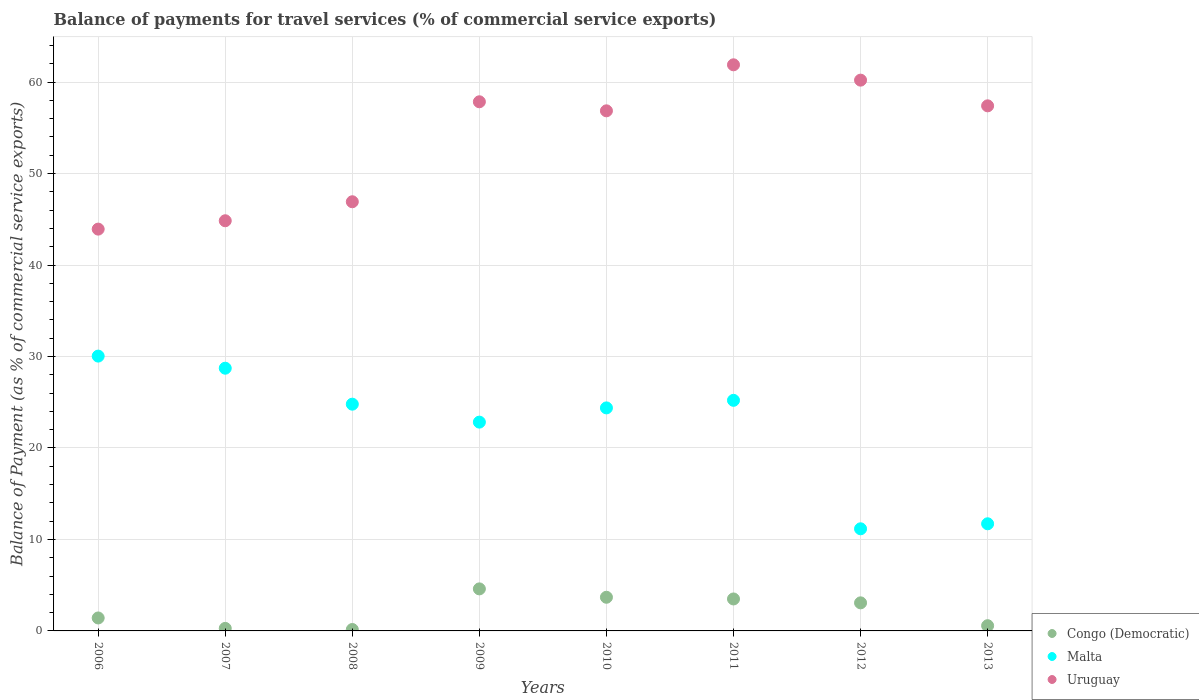How many different coloured dotlines are there?
Ensure brevity in your answer.  3. Is the number of dotlines equal to the number of legend labels?
Your answer should be compact. Yes. What is the balance of payments for travel services in Malta in 2010?
Offer a terse response. 24.38. Across all years, what is the maximum balance of payments for travel services in Malta?
Your answer should be compact. 30.05. Across all years, what is the minimum balance of payments for travel services in Congo (Democratic)?
Your response must be concise. 0.16. In which year was the balance of payments for travel services in Malta maximum?
Give a very brief answer. 2006. In which year was the balance of payments for travel services in Malta minimum?
Your response must be concise. 2012. What is the total balance of payments for travel services in Uruguay in the graph?
Make the answer very short. 429.91. What is the difference between the balance of payments for travel services in Uruguay in 2006 and that in 2010?
Give a very brief answer. -12.93. What is the difference between the balance of payments for travel services in Malta in 2013 and the balance of payments for travel services in Congo (Democratic) in 2008?
Offer a very short reply. 11.56. What is the average balance of payments for travel services in Malta per year?
Your answer should be compact. 22.36. In the year 2013, what is the difference between the balance of payments for travel services in Malta and balance of payments for travel services in Congo (Democratic)?
Offer a very short reply. 11.14. In how many years, is the balance of payments for travel services in Malta greater than 34 %?
Offer a very short reply. 0. What is the ratio of the balance of payments for travel services in Congo (Democratic) in 2006 to that in 2009?
Provide a short and direct response. 0.31. Is the difference between the balance of payments for travel services in Malta in 2006 and 2012 greater than the difference between the balance of payments for travel services in Congo (Democratic) in 2006 and 2012?
Provide a short and direct response. Yes. What is the difference between the highest and the second highest balance of payments for travel services in Malta?
Your answer should be compact. 1.32. What is the difference between the highest and the lowest balance of payments for travel services in Uruguay?
Make the answer very short. 17.96. Is it the case that in every year, the sum of the balance of payments for travel services in Congo (Democratic) and balance of payments for travel services in Uruguay  is greater than the balance of payments for travel services in Malta?
Your answer should be compact. Yes. Is the balance of payments for travel services in Malta strictly less than the balance of payments for travel services in Uruguay over the years?
Give a very brief answer. Yes. How many dotlines are there?
Offer a very short reply. 3. How many years are there in the graph?
Give a very brief answer. 8. What is the difference between two consecutive major ticks on the Y-axis?
Keep it short and to the point. 10. Are the values on the major ticks of Y-axis written in scientific E-notation?
Give a very brief answer. No. Does the graph contain any zero values?
Offer a terse response. No. How many legend labels are there?
Provide a succinct answer. 3. What is the title of the graph?
Offer a very short reply. Balance of payments for travel services (% of commercial service exports). Does "Chile" appear as one of the legend labels in the graph?
Give a very brief answer. No. What is the label or title of the Y-axis?
Offer a very short reply. Balance of Payment (as % of commercial service exports). What is the Balance of Payment (as % of commercial service exports) in Congo (Democratic) in 2006?
Offer a terse response. 1.42. What is the Balance of Payment (as % of commercial service exports) in Malta in 2006?
Give a very brief answer. 30.05. What is the Balance of Payment (as % of commercial service exports) of Uruguay in 2006?
Ensure brevity in your answer.  43.93. What is the Balance of Payment (as % of commercial service exports) in Congo (Democratic) in 2007?
Keep it short and to the point. 0.28. What is the Balance of Payment (as % of commercial service exports) in Malta in 2007?
Make the answer very short. 28.72. What is the Balance of Payment (as % of commercial service exports) in Uruguay in 2007?
Offer a very short reply. 44.84. What is the Balance of Payment (as % of commercial service exports) in Congo (Democratic) in 2008?
Give a very brief answer. 0.16. What is the Balance of Payment (as % of commercial service exports) in Malta in 2008?
Your response must be concise. 24.79. What is the Balance of Payment (as % of commercial service exports) in Uruguay in 2008?
Provide a short and direct response. 46.92. What is the Balance of Payment (as % of commercial service exports) of Congo (Democratic) in 2009?
Offer a very short reply. 4.6. What is the Balance of Payment (as % of commercial service exports) of Malta in 2009?
Offer a very short reply. 22.83. What is the Balance of Payment (as % of commercial service exports) in Uruguay in 2009?
Give a very brief answer. 57.85. What is the Balance of Payment (as % of commercial service exports) of Congo (Democratic) in 2010?
Provide a short and direct response. 3.68. What is the Balance of Payment (as % of commercial service exports) of Malta in 2010?
Ensure brevity in your answer.  24.38. What is the Balance of Payment (as % of commercial service exports) of Uruguay in 2010?
Keep it short and to the point. 56.86. What is the Balance of Payment (as % of commercial service exports) of Congo (Democratic) in 2011?
Provide a short and direct response. 3.49. What is the Balance of Payment (as % of commercial service exports) in Malta in 2011?
Make the answer very short. 25.21. What is the Balance of Payment (as % of commercial service exports) in Uruguay in 2011?
Keep it short and to the point. 61.89. What is the Balance of Payment (as % of commercial service exports) in Congo (Democratic) in 2012?
Make the answer very short. 3.07. What is the Balance of Payment (as % of commercial service exports) of Malta in 2012?
Give a very brief answer. 11.16. What is the Balance of Payment (as % of commercial service exports) in Uruguay in 2012?
Make the answer very short. 60.21. What is the Balance of Payment (as % of commercial service exports) of Congo (Democratic) in 2013?
Your answer should be compact. 0.57. What is the Balance of Payment (as % of commercial service exports) of Malta in 2013?
Keep it short and to the point. 11.71. What is the Balance of Payment (as % of commercial service exports) of Uruguay in 2013?
Provide a short and direct response. 57.41. Across all years, what is the maximum Balance of Payment (as % of commercial service exports) in Congo (Democratic)?
Keep it short and to the point. 4.6. Across all years, what is the maximum Balance of Payment (as % of commercial service exports) in Malta?
Offer a terse response. 30.05. Across all years, what is the maximum Balance of Payment (as % of commercial service exports) in Uruguay?
Your answer should be compact. 61.89. Across all years, what is the minimum Balance of Payment (as % of commercial service exports) of Congo (Democratic)?
Your answer should be compact. 0.16. Across all years, what is the minimum Balance of Payment (as % of commercial service exports) of Malta?
Provide a short and direct response. 11.16. Across all years, what is the minimum Balance of Payment (as % of commercial service exports) of Uruguay?
Ensure brevity in your answer.  43.93. What is the total Balance of Payment (as % of commercial service exports) in Congo (Democratic) in the graph?
Give a very brief answer. 17.26. What is the total Balance of Payment (as % of commercial service exports) in Malta in the graph?
Offer a very short reply. 178.85. What is the total Balance of Payment (as % of commercial service exports) of Uruguay in the graph?
Make the answer very short. 429.91. What is the difference between the Balance of Payment (as % of commercial service exports) in Congo (Democratic) in 2006 and that in 2007?
Offer a very short reply. 1.14. What is the difference between the Balance of Payment (as % of commercial service exports) of Malta in 2006 and that in 2007?
Make the answer very short. 1.32. What is the difference between the Balance of Payment (as % of commercial service exports) of Uruguay in 2006 and that in 2007?
Make the answer very short. -0.91. What is the difference between the Balance of Payment (as % of commercial service exports) in Congo (Democratic) in 2006 and that in 2008?
Your answer should be very brief. 1.26. What is the difference between the Balance of Payment (as % of commercial service exports) of Malta in 2006 and that in 2008?
Give a very brief answer. 5.26. What is the difference between the Balance of Payment (as % of commercial service exports) of Uruguay in 2006 and that in 2008?
Make the answer very short. -2.99. What is the difference between the Balance of Payment (as % of commercial service exports) of Congo (Democratic) in 2006 and that in 2009?
Your answer should be very brief. -3.18. What is the difference between the Balance of Payment (as % of commercial service exports) of Malta in 2006 and that in 2009?
Offer a very short reply. 7.22. What is the difference between the Balance of Payment (as % of commercial service exports) of Uruguay in 2006 and that in 2009?
Provide a succinct answer. -13.92. What is the difference between the Balance of Payment (as % of commercial service exports) in Congo (Democratic) in 2006 and that in 2010?
Provide a short and direct response. -2.26. What is the difference between the Balance of Payment (as % of commercial service exports) in Malta in 2006 and that in 2010?
Your response must be concise. 5.66. What is the difference between the Balance of Payment (as % of commercial service exports) in Uruguay in 2006 and that in 2010?
Offer a terse response. -12.93. What is the difference between the Balance of Payment (as % of commercial service exports) in Congo (Democratic) in 2006 and that in 2011?
Your answer should be very brief. -2.08. What is the difference between the Balance of Payment (as % of commercial service exports) of Malta in 2006 and that in 2011?
Offer a terse response. 4.84. What is the difference between the Balance of Payment (as % of commercial service exports) in Uruguay in 2006 and that in 2011?
Your answer should be compact. -17.96. What is the difference between the Balance of Payment (as % of commercial service exports) of Congo (Democratic) in 2006 and that in 2012?
Make the answer very short. -1.65. What is the difference between the Balance of Payment (as % of commercial service exports) of Malta in 2006 and that in 2012?
Your response must be concise. 18.88. What is the difference between the Balance of Payment (as % of commercial service exports) in Uruguay in 2006 and that in 2012?
Your response must be concise. -16.29. What is the difference between the Balance of Payment (as % of commercial service exports) in Congo (Democratic) in 2006 and that in 2013?
Your answer should be compact. 0.85. What is the difference between the Balance of Payment (as % of commercial service exports) in Malta in 2006 and that in 2013?
Provide a succinct answer. 18.33. What is the difference between the Balance of Payment (as % of commercial service exports) of Uruguay in 2006 and that in 2013?
Ensure brevity in your answer.  -13.48. What is the difference between the Balance of Payment (as % of commercial service exports) in Congo (Democratic) in 2007 and that in 2008?
Make the answer very short. 0.12. What is the difference between the Balance of Payment (as % of commercial service exports) of Malta in 2007 and that in 2008?
Your answer should be very brief. 3.93. What is the difference between the Balance of Payment (as % of commercial service exports) of Uruguay in 2007 and that in 2008?
Your answer should be compact. -2.08. What is the difference between the Balance of Payment (as % of commercial service exports) of Congo (Democratic) in 2007 and that in 2009?
Offer a terse response. -4.32. What is the difference between the Balance of Payment (as % of commercial service exports) in Malta in 2007 and that in 2009?
Provide a succinct answer. 5.9. What is the difference between the Balance of Payment (as % of commercial service exports) in Uruguay in 2007 and that in 2009?
Your response must be concise. -13.01. What is the difference between the Balance of Payment (as % of commercial service exports) of Congo (Democratic) in 2007 and that in 2010?
Provide a succinct answer. -3.4. What is the difference between the Balance of Payment (as % of commercial service exports) in Malta in 2007 and that in 2010?
Offer a terse response. 4.34. What is the difference between the Balance of Payment (as % of commercial service exports) in Uruguay in 2007 and that in 2010?
Your answer should be very brief. -12.02. What is the difference between the Balance of Payment (as % of commercial service exports) of Congo (Democratic) in 2007 and that in 2011?
Your answer should be very brief. -3.22. What is the difference between the Balance of Payment (as % of commercial service exports) of Malta in 2007 and that in 2011?
Your response must be concise. 3.51. What is the difference between the Balance of Payment (as % of commercial service exports) of Uruguay in 2007 and that in 2011?
Provide a succinct answer. -17.05. What is the difference between the Balance of Payment (as % of commercial service exports) of Congo (Democratic) in 2007 and that in 2012?
Offer a very short reply. -2.79. What is the difference between the Balance of Payment (as % of commercial service exports) of Malta in 2007 and that in 2012?
Your answer should be compact. 17.56. What is the difference between the Balance of Payment (as % of commercial service exports) of Uruguay in 2007 and that in 2012?
Make the answer very short. -15.37. What is the difference between the Balance of Payment (as % of commercial service exports) of Congo (Democratic) in 2007 and that in 2013?
Provide a short and direct response. -0.29. What is the difference between the Balance of Payment (as % of commercial service exports) of Malta in 2007 and that in 2013?
Offer a very short reply. 17.01. What is the difference between the Balance of Payment (as % of commercial service exports) of Uruguay in 2007 and that in 2013?
Ensure brevity in your answer.  -12.56. What is the difference between the Balance of Payment (as % of commercial service exports) of Congo (Democratic) in 2008 and that in 2009?
Give a very brief answer. -4.44. What is the difference between the Balance of Payment (as % of commercial service exports) of Malta in 2008 and that in 2009?
Provide a short and direct response. 1.96. What is the difference between the Balance of Payment (as % of commercial service exports) in Uruguay in 2008 and that in 2009?
Offer a very short reply. -10.93. What is the difference between the Balance of Payment (as % of commercial service exports) of Congo (Democratic) in 2008 and that in 2010?
Make the answer very short. -3.52. What is the difference between the Balance of Payment (as % of commercial service exports) in Malta in 2008 and that in 2010?
Provide a short and direct response. 0.41. What is the difference between the Balance of Payment (as % of commercial service exports) in Uruguay in 2008 and that in 2010?
Your answer should be very brief. -9.94. What is the difference between the Balance of Payment (as % of commercial service exports) of Congo (Democratic) in 2008 and that in 2011?
Your response must be concise. -3.34. What is the difference between the Balance of Payment (as % of commercial service exports) in Malta in 2008 and that in 2011?
Provide a succinct answer. -0.42. What is the difference between the Balance of Payment (as % of commercial service exports) of Uruguay in 2008 and that in 2011?
Your answer should be compact. -14.97. What is the difference between the Balance of Payment (as % of commercial service exports) of Congo (Democratic) in 2008 and that in 2012?
Offer a very short reply. -2.91. What is the difference between the Balance of Payment (as % of commercial service exports) in Malta in 2008 and that in 2012?
Provide a short and direct response. 13.62. What is the difference between the Balance of Payment (as % of commercial service exports) in Uruguay in 2008 and that in 2012?
Make the answer very short. -13.3. What is the difference between the Balance of Payment (as % of commercial service exports) of Congo (Democratic) in 2008 and that in 2013?
Ensure brevity in your answer.  -0.42. What is the difference between the Balance of Payment (as % of commercial service exports) in Malta in 2008 and that in 2013?
Provide a succinct answer. 13.08. What is the difference between the Balance of Payment (as % of commercial service exports) in Uruguay in 2008 and that in 2013?
Your response must be concise. -10.49. What is the difference between the Balance of Payment (as % of commercial service exports) of Congo (Democratic) in 2009 and that in 2010?
Offer a very short reply. 0.92. What is the difference between the Balance of Payment (as % of commercial service exports) in Malta in 2009 and that in 2010?
Your answer should be very brief. -1.55. What is the difference between the Balance of Payment (as % of commercial service exports) in Uruguay in 2009 and that in 2010?
Provide a succinct answer. 0.99. What is the difference between the Balance of Payment (as % of commercial service exports) in Congo (Democratic) in 2009 and that in 2011?
Offer a terse response. 1.1. What is the difference between the Balance of Payment (as % of commercial service exports) of Malta in 2009 and that in 2011?
Provide a succinct answer. -2.38. What is the difference between the Balance of Payment (as % of commercial service exports) in Uruguay in 2009 and that in 2011?
Your answer should be very brief. -4.04. What is the difference between the Balance of Payment (as % of commercial service exports) in Congo (Democratic) in 2009 and that in 2012?
Your answer should be very brief. 1.53. What is the difference between the Balance of Payment (as % of commercial service exports) of Malta in 2009 and that in 2012?
Offer a very short reply. 11.66. What is the difference between the Balance of Payment (as % of commercial service exports) of Uruguay in 2009 and that in 2012?
Give a very brief answer. -2.37. What is the difference between the Balance of Payment (as % of commercial service exports) of Congo (Democratic) in 2009 and that in 2013?
Keep it short and to the point. 4.02. What is the difference between the Balance of Payment (as % of commercial service exports) in Malta in 2009 and that in 2013?
Offer a very short reply. 11.11. What is the difference between the Balance of Payment (as % of commercial service exports) in Uruguay in 2009 and that in 2013?
Your answer should be compact. 0.44. What is the difference between the Balance of Payment (as % of commercial service exports) in Congo (Democratic) in 2010 and that in 2011?
Offer a terse response. 0.18. What is the difference between the Balance of Payment (as % of commercial service exports) in Malta in 2010 and that in 2011?
Keep it short and to the point. -0.83. What is the difference between the Balance of Payment (as % of commercial service exports) of Uruguay in 2010 and that in 2011?
Keep it short and to the point. -5.03. What is the difference between the Balance of Payment (as % of commercial service exports) of Congo (Democratic) in 2010 and that in 2012?
Your answer should be very brief. 0.61. What is the difference between the Balance of Payment (as % of commercial service exports) in Malta in 2010 and that in 2012?
Offer a very short reply. 13.22. What is the difference between the Balance of Payment (as % of commercial service exports) in Uruguay in 2010 and that in 2012?
Provide a short and direct response. -3.35. What is the difference between the Balance of Payment (as % of commercial service exports) of Congo (Democratic) in 2010 and that in 2013?
Make the answer very short. 3.11. What is the difference between the Balance of Payment (as % of commercial service exports) of Malta in 2010 and that in 2013?
Make the answer very short. 12.67. What is the difference between the Balance of Payment (as % of commercial service exports) in Uruguay in 2010 and that in 2013?
Keep it short and to the point. -0.55. What is the difference between the Balance of Payment (as % of commercial service exports) in Congo (Democratic) in 2011 and that in 2012?
Your answer should be very brief. 0.43. What is the difference between the Balance of Payment (as % of commercial service exports) in Malta in 2011 and that in 2012?
Make the answer very short. 14.04. What is the difference between the Balance of Payment (as % of commercial service exports) in Uruguay in 2011 and that in 2012?
Make the answer very short. 1.68. What is the difference between the Balance of Payment (as % of commercial service exports) in Congo (Democratic) in 2011 and that in 2013?
Make the answer very short. 2.92. What is the difference between the Balance of Payment (as % of commercial service exports) of Malta in 2011 and that in 2013?
Provide a short and direct response. 13.5. What is the difference between the Balance of Payment (as % of commercial service exports) of Uruguay in 2011 and that in 2013?
Your answer should be compact. 4.49. What is the difference between the Balance of Payment (as % of commercial service exports) of Congo (Democratic) in 2012 and that in 2013?
Offer a terse response. 2.5. What is the difference between the Balance of Payment (as % of commercial service exports) in Malta in 2012 and that in 2013?
Give a very brief answer. -0.55. What is the difference between the Balance of Payment (as % of commercial service exports) in Uruguay in 2012 and that in 2013?
Provide a succinct answer. 2.81. What is the difference between the Balance of Payment (as % of commercial service exports) of Congo (Democratic) in 2006 and the Balance of Payment (as % of commercial service exports) of Malta in 2007?
Provide a succinct answer. -27.31. What is the difference between the Balance of Payment (as % of commercial service exports) in Congo (Democratic) in 2006 and the Balance of Payment (as % of commercial service exports) in Uruguay in 2007?
Your response must be concise. -43.43. What is the difference between the Balance of Payment (as % of commercial service exports) of Malta in 2006 and the Balance of Payment (as % of commercial service exports) of Uruguay in 2007?
Offer a very short reply. -14.8. What is the difference between the Balance of Payment (as % of commercial service exports) of Congo (Democratic) in 2006 and the Balance of Payment (as % of commercial service exports) of Malta in 2008?
Provide a succinct answer. -23.37. What is the difference between the Balance of Payment (as % of commercial service exports) of Congo (Democratic) in 2006 and the Balance of Payment (as % of commercial service exports) of Uruguay in 2008?
Your response must be concise. -45.5. What is the difference between the Balance of Payment (as % of commercial service exports) in Malta in 2006 and the Balance of Payment (as % of commercial service exports) in Uruguay in 2008?
Give a very brief answer. -16.87. What is the difference between the Balance of Payment (as % of commercial service exports) of Congo (Democratic) in 2006 and the Balance of Payment (as % of commercial service exports) of Malta in 2009?
Your answer should be very brief. -21.41. What is the difference between the Balance of Payment (as % of commercial service exports) in Congo (Democratic) in 2006 and the Balance of Payment (as % of commercial service exports) in Uruguay in 2009?
Provide a short and direct response. -56.43. What is the difference between the Balance of Payment (as % of commercial service exports) of Malta in 2006 and the Balance of Payment (as % of commercial service exports) of Uruguay in 2009?
Ensure brevity in your answer.  -27.8. What is the difference between the Balance of Payment (as % of commercial service exports) of Congo (Democratic) in 2006 and the Balance of Payment (as % of commercial service exports) of Malta in 2010?
Offer a very short reply. -22.96. What is the difference between the Balance of Payment (as % of commercial service exports) in Congo (Democratic) in 2006 and the Balance of Payment (as % of commercial service exports) in Uruguay in 2010?
Provide a succinct answer. -55.44. What is the difference between the Balance of Payment (as % of commercial service exports) in Malta in 2006 and the Balance of Payment (as % of commercial service exports) in Uruguay in 2010?
Make the answer very short. -26.81. What is the difference between the Balance of Payment (as % of commercial service exports) in Congo (Democratic) in 2006 and the Balance of Payment (as % of commercial service exports) in Malta in 2011?
Provide a short and direct response. -23.79. What is the difference between the Balance of Payment (as % of commercial service exports) in Congo (Democratic) in 2006 and the Balance of Payment (as % of commercial service exports) in Uruguay in 2011?
Give a very brief answer. -60.47. What is the difference between the Balance of Payment (as % of commercial service exports) in Malta in 2006 and the Balance of Payment (as % of commercial service exports) in Uruguay in 2011?
Give a very brief answer. -31.85. What is the difference between the Balance of Payment (as % of commercial service exports) in Congo (Democratic) in 2006 and the Balance of Payment (as % of commercial service exports) in Malta in 2012?
Your response must be concise. -9.75. What is the difference between the Balance of Payment (as % of commercial service exports) in Congo (Democratic) in 2006 and the Balance of Payment (as % of commercial service exports) in Uruguay in 2012?
Your answer should be very brief. -58.8. What is the difference between the Balance of Payment (as % of commercial service exports) of Malta in 2006 and the Balance of Payment (as % of commercial service exports) of Uruguay in 2012?
Provide a short and direct response. -30.17. What is the difference between the Balance of Payment (as % of commercial service exports) in Congo (Democratic) in 2006 and the Balance of Payment (as % of commercial service exports) in Malta in 2013?
Ensure brevity in your answer.  -10.3. What is the difference between the Balance of Payment (as % of commercial service exports) of Congo (Democratic) in 2006 and the Balance of Payment (as % of commercial service exports) of Uruguay in 2013?
Your answer should be very brief. -55.99. What is the difference between the Balance of Payment (as % of commercial service exports) of Malta in 2006 and the Balance of Payment (as % of commercial service exports) of Uruguay in 2013?
Your answer should be compact. -27.36. What is the difference between the Balance of Payment (as % of commercial service exports) in Congo (Democratic) in 2007 and the Balance of Payment (as % of commercial service exports) in Malta in 2008?
Ensure brevity in your answer.  -24.51. What is the difference between the Balance of Payment (as % of commercial service exports) in Congo (Democratic) in 2007 and the Balance of Payment (as % of commercial service exports) in Uruguay in 2008?
Provide a succinct answer. -46.64. What is the difference between the Balance of Payment (as % of commercial service exports) of Malta in 2007 and the Balance of Payment (as % of commercial service exports) of Uruguay in 2008?
Keep it short and to the point. -18.2. What is the difference between the Balance of Payment (as % of commercial service exports) of Congo (Democratic) in 2007 and the Balance of Payment (as % of commercial service exports) of Malta in 2009?
Offer a very short reply. -22.55. What is the difference between the Balance of Payment (as % of commercial service exports) of Congo (Democratic) in 2007 and the Balance of Payment (as % of commercial service exports) of Uruguay in 2009?
Your response must be concise. -57.57. What is the difference between the Balance of Payment (as % of commercial service exports) in Malta in 2007 and the Balance of Payment (as % of commercial service exports) in Uruguay in 2009?
Your answer should be compact. -29.13. What is the difference between the Balance of Payment (as % of commercial service exports) of Congo (Democratic) in 2007 and the Balance of Payment (as % of commercial service exports) of Malta in 2010?
Offer a very short reply. -24.11. What is the difference between the Balance of Payment (as % of commercial service exports) of Congo (Democratic) in 2007 and the Balance of Payment (as % of commercial service exports) of Uruguay in 2010?
Your answer should be very brief. -56.58. What is the difference between the Balance of Payment (as % of commercial service exports) of Malta in 2007 and the Balance of Payment (as % of commercial service exports) of Uruguay in 2010?
Ensure brevity in your answer.  -28.14. What is the difference between the Balance of Payment (as % of commercial service exports) of Congo (Democratic) in 2007 and the Balance of Payment (as % of commercial service exports) of Malta in 2011?
Give a very brief answer. -24.93. What is the difference between the Balance of Payment (as % of commercial service exports) of Congo (Democratic) in 2007 and the Balance of Payment (as % of commercial service exports) of Uruguay in 2011?
Provide a succinct answer. -61.61. What is the difference between the Balance of Payment (as % of commercial service exports) of Malta in 2007 and the Balance of Payment (as % of commercial service exports) of Uruguay in 2011?
Provide a succinct answer. -33.17. What is the difference between the Balance of Payment (as % of commercial service exports) in Congo (Democratic) in 2007 and the Balance of Payment (as % of commercial service exports) in Malta in 2012?
Provide a succinct answer. -10.89. What is the difference between the Balance of Payment (as % of commercial service exports) of Congo (Democratic) in 2007 and the Balance of Payment (as % of commercial service exports) of Uruguay in 2012?
Your answer should be very brief. -59.94. What is the difference between the Balance of Payment (as % of commercial service exports) in Malta in 2007 and the Balance of Payment (as % of commercial service exports) in Uruguay in 2012?
Give a very brief answer. -31.49. What is the difference between the Balance of Payment (as % of commercial service exports) of Congo (Democratic) in 2007 and the Balance of Payment (as % of commercial service exports) of Malta in 2013?
Provide a succinct answer. -11.44. What is the difference between the Balance of Payment (as % of commercial service exports) of Congo (Democratic) in 2007 and the Balance of Payment (as % of commercial service exports) of Uruguay in 2013?
Give a very brief answer. -57.13. What is the difference between the Balance of Payment (as % of commercial service exports) of Malta in 2007 and the Balance of Payment (as % of commercial service exports) of Uruguay in 2013?
Give a very brief answer. -28.68. What is the difference between the Balance of Payment (as % of commercial service exports) in Congo (Democratic) in 2008 and the Balance of Payment (as % of commercial service exports) in Malta in 2009?
Ensure brevity in your answer.  -22.67. What is the difference between the Balance of Payment (as % of commercial service exports) of Congo (Democratic) in 2008 and the Balance of Payment (as % of commercial service exports) of Uruguay in 2009?
Your answer should be very brief. -57.69. What is the difference between the Balance of Payment (as % of commercial service exports) in Malta in 2008 and the Balance of Payment (as % of commercial service exports) in Uruguay in 2009?
Provide a succinct answer. -33.06. What is the difference between the Balance of Payment (as % of commercial service exports) in Congo (Democratic) in 2008 and the Balance of Payment (as % of commercial service exports) in Malta in 2010?
Offer a very short reply. -24.23. What is the difference between the Balance of Payment (as % of commercial service exports) in Congo (Democratic) in 2008 and the Balance of Payment (as % of commercial service exports) in Uruguay in 2010?
Provide a short and direct response. -56.7. What is the difference between the Balance of Payment (as % of commercial service exports) in Malta in 2008 and the Balance of Payment (as % of commercial service exports) in Uruguay in 2010?
Your answer should be very brief. -32.07. What is the difference between the Balance of Payment (as % of commercial service exports) of Congo (Democratic) in 2008 and the Balance of Payment (as % of commercial service exports) of Malta in 2011?
Make the answer very short. -25.05. What is the difference between the Balance of Payment (as % of commercial service exports) in Congo (Democratic) in 2008 and the Balance of Payment (as % of commercial service exports) in Uruguay in 2011?
Provide a short and direct response. -61.74. What is the difference between the Balance of Payment (as % of commercial service exports) in Malta in 2008 and the Balance of Payment (as % of commercial service exports) in Uruguay in 2011?
Your response must be concise. -37.1. What is the difference between the Balance of Payment (as % of commercial service exports) of Congo (Democratic) in 2008 and the Balance of Payment (as % of commercial service exports) of Malta in 2012?
Offer a terse response. -11.01. What is the difference between the Balance of Payment (as % of commercial service exports) in Congo (Democratic) in 2008 and the Balance of Payment (as % of commercial service exports) in Uruguay in 2012?
Provide a succinct answer. -60.06. What is the difference between the Balance of Payment (as % of commercial service exports) in Malta in 2008 and the Balance of Payment (as % of commercial service exports) in Uruguay in 2012?
Make the answer very short. -35.43. What is the difference between the Balance of Payment (as % of commercial service exports) of Congo (Democratic) in 2008 and the Balance of Payment (as % of commercial service exports) of Malta in 2013?
Offer a terse response. -11.56. What is the difference between the Balance of Payment (as % of commercial service exports) of Congo (Democratic) in 2008 and the Balance of Payment (as % of commercial service exports) of Uruguay in 2013?
Your answer should be very brief. -57.25. What is the difference between the Balance of Payment (as % of commercial service exports) of Malta in 2008 and the Balance of Payment (as % of commercial service exports) of Uruguay in 2013?
Ensure brevity in your answer.  -32.62. What is the difference between the Balance of Payment (as % of commercial service exports) of Congo (Democratic) in 2009 and the Balance of Payment (as % of commercial service exports) of Malta in 2010?
Make the answer very short. -19.79. What is the difference between the Balance of Payment (as % of commercial service exports) in Congo (Democratic) in 2009 and the Balance of Payment (as % of commercial service exports) in Uruguay in 2010?
Your answer should be compact. -52.26. What is the difference between the Balance of Payment (as % of commercial service exports) in Malta in 2009 and the Balance of Payment (as % of commercial service exports) in Uruguay in 2010?
Your answer should be compact. -34.03. What is the difference between the Balance of Payment (as % of commercial service exports) of Congo (Democratic) in 2009 and the Balance of Payment (as % of commercial service exports) of Malta in 2011?
Your response must be concise. -20.61. What is the difference between the Balance of Payment (as % of commercial service exports) in Congo (Democratic) in 2009 and the Balance of Payment (as % of commercial service exports) in Uruguay in 2011?
Your answer should be very brief. -57.29. What is the difference between the Balance of Payment (as % of commercial service exports) of Malta in 2009 and the Balance of Payment (as % of commercial service exports) of Uruguay in 2011?
Your response must be concise. -39.06. What is the difference between the Balance of Payment (as % of commercial service exports) of Congo (Democratic) in 2009 and the Balance of Payment (as % of commercial service exports) of Malta in 2012?
Keep it short and to the point. -6.57. What is the difference between the Balance of Payment (as % of commercial service exports) of Congo (Democratic) in 2009 and the Balance of Payment (as % of commercial service exports) of Uruguay in 2012?
Keep it short and to the point. -55.62. What is the difference between the Balance of Payment (as % of commercial service exports) of Malta in 2009 and the Balance of Payment (as % of commercial service exports) of Uruguay in 2012?
Keep it short and to the point. -37.39. What is the difference between the Balance of Payment (as % of commercial service exports) of Congo (Democratic) in 2009 and the Balance of Payment (as % of commercial service exports) of Malta in 2013?
Provide a short and direct response. -7.12. What is the difference between the Balance of Payment (as % of commercial service exports) of Congo (Democratic) in 2009 and the Balance of Payment (as % of commercial service exports) of Uruguay in 2013?
Your answer should be very brief. -52.81. What is the difference between the Balance of Payment (as % of commercial service exports) in Malta in 2009 and the Balance of Payment (as % of commercial service exports) in Uruguay in 2013?
Offer a very short reply. -34.58. What is the difference between the Balance of Payment (as % of commercial service exports) of Congo (Democratic) in 2010 and the Balance of Payment (as % of commercial service exports) of Malta in 2011?
Your answer should be very brief. -21.53. What is the difference between the Balance of Payment (as % of commercial service exports) of Congo (Democratic) in 2010 and the Balance of Payment (as % of commercial service exports) of Uruguay in 2011?
Provide a short and direct response. -58.21. What is the difference between the Balance of Payment (as % of commercial service exports) in Malta in 2010 and the Balance of Payment (as % of commercial service exports) in Uruguay in 2011?
Offer a terse response. -37.51. What is the difference between the Balance of Payment (as % of commercial service exports) in Congo (Democratic) in 2010 and the Balance of Payment (as % of commercial service exports) in Malta in 2012?
Your answer should be very brief. -7.49. What is the difference between the Balance of Payment (as % of commercial service exports) in Congo (Democratic) in 2010 and the Balance of Payment (as % of commercial service exports) in Uruguay in 2012?
Your answer should be very brief. -56.54. What is the difference between the Balance of Payment (as % of commercial service exports) in Malta in 2010 and the Balance of Payment (as % of commercial service exports) in Uruguay in 2012?
Make the answer very short. -35.83. What is the difference between the Balance of Payment (as % of commercial service exports) in Congo (Democratic) in 2010 and the Balance of Payment (as % of commercial service exports) in Malta in 2013?
Your response must be concise. -8.03. What is the difference between the Balance of Payment (as % of commercial service exports) of Congo (Democratic) in 2010 and the Balance of Payment (as % of commercial service exports) of Uruguay in 2013?
Give a very brief answer. -53.73. What is the difference between the Balance of Payment (as % of commercial service exports) in Malta in 2010 and the Balance of Payment (as % of commercial service exports) in Uruguay in 2013?
Offer a very short reply. -33.02. What is the difference between the Balance of Payment (as % of commercial service exports) of Congo (Democratic) in 2011 and the Balance of Payment (as % of commercial service exports) of Malta in 2012?
Offer a very short reply. -7.67. What is the difference between the Balance of Payment (as % of commercial service exports) in Congo (Democratic) in 2011 and the Balance of Payment (as % of commercial service exports) in Uruguay in 2012?
Offer a terse response. -56.72. What is the difference between the Balance of Payment (as % of commercial service exports) in Malta in 2011 and the Balance of Payment (as % of commercial service exports) in Uruguay in 2012?
Make the answer very short. -35.01. What is the difference between the Balance of Payment (as % of commercial service exports) of Congo (Democratic) in 2011 and the Balance of Payment (as % of commercial service exports) of Malta in 2013?
Your answer should be very brief. -8.22. What is the difference between the Balance of Payment (as % of commercial service exports) of Congo (Democratic) in 2011 and the Balance of Payment (as % of commercial service exports) of Uruguay in 2013?
Your answer should be very brief. -53.91. What is the difference between the Balance of Payment (as % of commercial service exports) of Malta in 2011 and the Balance of Payment (as % of commercial service exports) of Uruguay in 2013?
Keep it short and to the point. -32.2. What is the difference between the Balance of Payment (as % of commercial service exports) of Congo (Democratic) in 2012 and the Balance of Payment (as % of commercial service exports) of Malta in 2013?
Make the answer very short. -8.64. What is the difference between the Balance of Payment (as % of commercial service exports) in Congo (Democratic) in 2012 and the Balance of Payment (as % of commercial service exports) in Uruguay in 2013?
Your answer should be very brief. -54.34. What is the difference between the Balance of Payment (as % of commercial service exports) of Malta in 2012 and the Balance of Payment (as % of commercial service exports) of Uruguay in 2013?
Give a very brief answer. -46.24. What is the average Balance of Payment (as % of commercial service exports) of Congo (Democratic) per year?
Your answer should be very brief. 2.16. What is the average Balance of Payment (as % of commercial service exports) in Malta per year?
Offer a very short reply. 22.36. What is the average Balance of Payment (as % of commercial service exports) of Uruguay per year?
Provide a succinct answer. 53.74. In the year 2006, what is the difference between the Balance of Payment (as % of commercial service exports) of Congo (Democratic) and Balance of Payment (as % of commercial service exports) of Malta?
Your answer should be very brief. -28.63. In the year 2006, what is the difference between the Balance of Payment (as % of commercial service exports) in Congo (Democratic) and Balance of Payment (as % of commercial service exports) in Uruguay?
Offer a very short reply. -42.51. In the year 2006, what is the difference between the Balance of Payment (as % of commercial service exports) in Malta and Balance of Payment (as % of commercial service exports) in Uruguay?
Provide a short and direct response. -13.88. In the year 2007, what is the difference between the Balance of Payment (as % of commercial service exports) of Congo (Democratic) and Balance of Payment (as % of commercial service exports) of Malta?
Provide a short and direct response. -28.45. In the year 2007, what is the difference between the Balance of Payment (as % of commercial service exports) in Congo (Democratic) and Balance of Payment (as % of commercial service exports) in Uruguay?
Your answer should be compact. -44.57. In the year 2007, what is the difference between the Balance of Payment (as % of commercial service exports) of Malta and Balance of Payment (as % of commercial service exports) of Uruguay?
Provide a short and direct response. -16.12. In the year 2008, what is the difference between the Balance of Payment (as % of commercial service exports) of Congo (Democratic) and Balance of Payment (as % of commercial service exports) of Malta?
Keep it short and to the point. -24.63. In the year 2008, what is the difference between the Balance of Payment (as % of commercial service exports) of Congo (Democratic) and Balance of Payment (as % of commercial service exports) of Uruguay?
Make the answer very short. -46.76. In the year 2008, what is the difference between the Balance of Payment (as % of commercial service exports) of Malta and Balance of Payment (as % of commercial service exports) of Uruguay?
Make the answer very short. -22.13. In the year 2009, what is the difference between the Balance of Payment (as % of commercial service exports) in Congo (Democratic) and Balance of Payment (as % of commercial service exports) in Malta?
Keep it short and to the point. -18.23. In the year 2009, what is the difference between the Balance of Payment (as % of commercial service exports) in Congo (Democratic) and Balance of Payment (as % of commercial service exports) in Uruguay?
Give a very brief answer. -53.25. In the year 2009, what is the difference between the Balance of Payment (as % of commercial service exports) in Malta and Balance of Payment (as % of commercial service exports) in Uruguay?
Offer a terse response. -35.02. In the year 2010, what is the difference between the Balance of Payment (as % of commercial service exports) in Congo (Democratic) and Balance of Payment (as % of commercial service exports) in Malta?
Provide a succinct answer. -20.7. In the year 2010, what is the difference between the Balance of Payment (as % of commercial service exports) in Congo (Democratic) and Balance of Payment (as % of commercial service exports) in Uruguay?
Ensure brevity in your answer.  -53.18. In the year 2010, what is the difference between the Balance of Payment (as % of commercial service exports) in Malta and Balance of Payment (as % of commercial service exports) in Uruguay?
Make the answer very short. -32.48. In the year 2011, what is the difference between the Balance of Payment (as % of commercial service exports) of Congo (Democratic) and Balance of Payment (as % of commercial service exports) of Malta?
Make the answer very short. -21.71. In the year 2011, what is the difference between the Balance of Payment (as % of commercial service exports) of Congo (Democratic) and Balance of Payment (as % of commercial service exports) of Uruguay?
Provide a succinct answer. -58.4. In the year 2011, what is the difference between the Balance of Payment (as % of commercial service exports) in Malta and Balance of Payment (as % of commercial service exports) in Uruguay?
Keep it short and to the point. -36.68. In the year 2012, what is the difference between the Balance of Payment (as % of commercial service exports) in Congo (Democratic) and Balance of Payment (as % of commercial service exports) in Malta?
Your response must be concise. -8.1. In the year 2012, what is the difference between the Balance of Payment (as % of commercial service exports) of Congo (Democratic) and Balance of Payment (as % of commercial service exports) of Uruguay?
Provide a succinct answer. -57.15. In the year 2012, what is the difference between the Balance of Payment (as % of commercial service exports) in Malta and Balance of Payment (as % of commercial service exports) in Uruguay?
Your answer should be compact. -49.05. In the year 2013, what is the difference between the Balance of Payment (as % of commercial service exports) of Congo (Democratic) and Balance of Payment (as % of commercial service exports) of Malta?
Keep it short and to the point. -11.14. In the year 2013, what is the difference between the Balance of Payment (as % of commercial service exports) of Congo (Democratic) and Balance of Payment (as % of commercial service exports) of Uruguay?
Provide a short and direct response. -56.83. In the year 2013, what is the difference between the Balance of Payment (as % of commercial service exports) in Malta and Balance of Payment (as % of commercial service exports) in Uruguay?
Offer a very short reply. -45.69. What is the ratio of the Balance of Payment (as % of commercial service exports) in Congo (Democratic) in 2006 to that in 2007?
Provide a short and direct response. 5.13. What is the ratio of the Balance of Payment (as % of commercial service exports) in Malta in 2006 to that in 2007?
Your answer should be compact. 1.05. What is the ratio of the Balance of Payment (as % of commercial service exports) in Uruguay in 2006 to that in 2007?
Your answer should be very brief. 0.98. What is the ratio of the Balance of Payment (as % of commercial service exports) in Congo (Democratic) in 2006 to that in 2008?
Your answer should be very brief. 9.12. What is the ratio of the Balance of Payment (as % of commercial service exports) of Malta in 2006 to that in 2008?
Keep it short and to the point. 1.21. What is the ratio of the Balance of Payment (as % of commercial service exports) of Uruguay in 2006 to that in 2008?
Provide a succinct answer. 0.94. What is the ratio of the Balance of Payment (as % of commercial service exports) in Congo (Democratic) in 2006 to that in 2009?
Your response must be concise. 0.31. What is the ratio of the Balance of Payment (as % of commercial service exports) of Malta in 2006 to that in 2009?
Keep it short and to the point. 1.32. What is the ratio of the Balance of Payment (as % of commercial service exports) in Uruguay in 2006 to that in 2009?
Your response must be concise. 0.76. What is the ratio of the Balance of Payment (as % of commercial service exports) in Congo (Democratic) in 2006 to that in 2010?
Provide a succinct answer. 0.39. What is the ratio of the Balance of Payment (as % of commercial service exports) in Malta in 2006 to that in 2010?
Your answer should be very brief. 1.23. What is the ratio of the Balance of Payment (as % of commercial service exports) of Uruguay in 2006 to that in 2010?
Offer a very short reply. 0.77. What is the ratio of the Balance of Payment (as % of commercial service exports) of Congo (Democratic) in 2006 to that in 2011?
Provide a short and direct response. 0.41. What is the ratio of the Balance of Payment (as % of commercial service exports) in Malta in 2006 to that in 2011?
Give a very brief answer. 1.19. What is the ratio of the Balance of Payment (as % of commercial service exports) of Uruguay in 2006 to that in 2011?
Ensure brevity in your answer.  0.71. What is the ratio of the Balance of Payment (as % of commercial service exports) of Congo (Democratic) in 2006 to that in 2012?
Give a very brief answer. 0.46. What is the ratio of the Balance of Payment (as % of commercial service exports) of Malta in 2006 to that in 2012?
Offer a terse response. 2.69. What is the ratio of the Balance of Payment (as % of commercial service exports) of Uruguay in 2006 to that in 2012?
Offer a terse response. 0.73. What is the ratio of the Balance of Payment (as % of commercial service exports) of Congo (Democratic) in 2006 to that in 2013?
Ensure brevity in your answer.  2.48. What is the ratio of the Balance of Payment (as % of commercial service exports) in Malta in 2006 to that in 2013?
Your response must be concise. 2.57. What is the ratio of the Balance of Payment (as % of commercial service exports) of Uruguay in 2006 to that in 2013?
Give a very brief answer. 0.77. What is the ratio of the Balance of Payment (as % of commercial service exports) of Congo (Democratic) in 2007 to that in 2008?
Make the answer very short. 1.78. What is the ratio of the Balance of Payment (as % of commercial service exports) in Malta in 2007 to that in 2008?
Keep it short and to the point. 1.16. What is the ratio of the Balance of Payment (as % of commercial service exports) of Uruguay in 2007 to that in 2008?
Offer a terse response. 0.96. What is the ratio of the Balance of Payment (as % of commercial service exports) of Congo (Democratic) in 2007 to that in 2009?
Your response must be concise. 0.06. What is the ratio of the Balance of Payment (as % of commercial service exports) of Malta in 2007 to that in 2009?
Offer a terse response. 1.26. What is the ratio of the Balance of Payment (as % of commercial service exports) of Uruguay in 2007 to that in 2009?
Make the answer very short. 0.78. What is the ratio of the Balance of Payment (as % of commercial service exports) of Congo (Democratic) in 2007 to that in 2010?
Your answer should be compact. 0.08. What is the ratio of the Balance of Payment (as % of commercial service exports) in Malta in 2007 to that in 2010?
Ensure brevity in your answer.  1.18. What is the ratio of the Balance of Payment (as % of commercial service exports) of Uruguay in 2007 to that in 2010?
Provide a succinct answer. 0.79. What is the ratio of the Balance of Payment (as % of commercial service exports) in Congo (Democratic) in 2007 to that in 2011?
Give a very brief answer. 0.08. What is the ratio of the Balance of Payment (as % of commercial service exports) of Malta in 2007 to that in 2011?
Keep it short and to the point. 1.14. What is the ratio of the Balance of Payment (as % of commercial service exports) in Uruguay in 2007 to that in 2011?
Your answer should be very brief. 0.72. What is the ratio of the Balance of Payment (as % of commercial service exports) of Congo (Democratic) in 2007 to that in 2012?
Keep it short and to the point. 0.09. What is the ratio of the Balance of Payment (as % of commercial service exports) in Malta in 2007 to that in 2012?
Your answer should be very brief. 2.57. What is the ratio of the Balance of Payment (as % of commercial service exports) in Uruguay in 2007 to that in 2012?
Offer a terse response. 0.74. What is the ratio of the Balance of Payment (as % of commercial service exports) of Congo (Democratic) in 2007 to that in 2013?
Your answer should be compact. 0.48. What is the ratio of the Balance of Payment (as % of commercial service exports) in Malta in 2007 to that in 2013?
Offer a terse response. 2.45. What is the ratio of the Balance of Payment (as % of commercial service exports) in Uruguay in 2007 to that in 2013?
Your answer should be very brief. 0.78. What is the ratio of the Balance of Payment (as % of commercial service exports) in Congo (Democratic) in 2008 to that in 2009?
Make the answer very short. 0.03. What is the ratio of the Balance of Payment (as % of commercial service exports) in Malta in 2008 to that in 2009?
Offer a very short reply. 1.09. What is the ratio of the Balance of Payment (as % of commercial service exports) of Uruguay in 2008 to that in 2009?
Give a very brief answer. 0.81. What is the ratio of the Balance of Payment (as % of commercial service exports) in Congo (Democratic) in 2008 to that in 2010?
Keep it short and to the point. 0.04. What is the ratio of the Balance of Payment (as % of commercial service exports) of Malta in 2008 to that in 2010?
Keep it short and to the point. 1.02. What is the ratio of the Balance of Payment (as % of commercial service exports) in Uruguay in 2008 to that in 2010?
Keep it short and to the point. 0.83. What is the ratio of the Balance of Payment (as % of commercial service exports) in Congo (Democratic) in 2008 to that in 2011?
Your response must be concise. 0.04. What is the ratio of the Balance of Payment (as % of commercial service exports) of Malta in 2008 to that in 2011?
Give a very brief answer. 0.98. What is the ratio of the Balance of Payment (as % of commercial service exports) of Uruguay in 2008 to that in 2011?
Your answer should be compact. 0.76. What is the ratio of the Balance of Payment (as % of commercial service exports) in Congo (Democratic) in 2008 to that in 2012?
Ensure brevity in your answer.  0.05. What is the ratio of the Balance of Payment (as % of commercial service exports) in Malta in 2008 to that in 2012?
Provide a short and direct response. 2.22. What is the ratio of the Balance of Payment (as % of commercial service exports) of Uruguay in 2008 to that in 2012?
Your answer should be very brief. 0.78. What is the ratio of the Balance of Payment (as % of commercial service exports) in Congo (Democratic) in 2008 to that in 2013?
Provide a succinct answer. 0.27. What is the ratio of the Balance of Payment (as % of commercial service exports) in Malta in 2008 to that in 2013?
Provide a succinct answer. 2.12. What is the ratio of the Balance of Payment (as % of commercial service exports) in Uruguay in 2008 to that in 2013?
Ensure brevity in your answer.  0.82. What is the ratio of the Balance of Payment (as % of commercial service exports) in Congo (Democratic) in 2009 to that in 2010?
Your response must be concise. 1.25. What is the ratio of the Balance of Payment (as % of commercial service exports) in Malta in 2009 to that in 2010?
Provide a short and direct response. 0.94. What is the ratio of the Balance of Payment (as % of commercial service exports) in Uruguay in 2009 to that in 2010?
Your answer should be very brief. 1.02. What is the ratio of the Balance of Payment (as % of commercial service exports) of Congo (Democratic) in 2009 to that in 2011?
Your answer should be very brief. 1.32. What is the ratio of the Balance of Payment (as % of commercial service exports) of Malta in 2009 to that in 2011?
Keep it short and to the point. 0.91. What is the ratio of the Balance of Payment (as % of commercial service exports) of Uruguay in 2009 to that in 2011?
Make the answer very short. 0.93. What is the ratio of the Balance of Payment (as % of commercial service exports) of Congo (Democratic) in 2009 to that in 2012?
Keep it short and to the point. 1.5. What is the ratio of the Balance of Payment (as % of commercial service exports) of Malta in 2009 to that in 2012?
Your answer should be compact. 2.04. What is the ratio of the Balance of Payment (as % of commercial service exports) of Uruguay in 2009 to that in 2012?
Provide a short and direct response. 0.96. What is the ratio of the Balance of Payment (as % of commercial service exports) of Congo (Democratic) in 2009 to that in 2013?
Provide a short and direct response. 8.05. What is the ratio of the Balance of Payment (as % of commercial service exports) in Malta in 2009 to that in 2013?
Ensure brevity in your answer.  1.95. What is the ratio of the Balance of Payment (as % of commercial service exports) in Uruguay in 2009 to that in 2013?
Provide a short and direct response. 1.01. What is the ratio of the Balance of Payment (as % of commercial service exports) of Congo (Democratic) in 2010 to that in 2011?
Keep it short and to the point. 1.05. What is the ratio of the Balance of Payment (as % of commercial service exports) of Malta in 2010 to that in 2011?
Offer a terse response. 0.97. What is the ratio of the Balance of Payment (as % of commercial service exports) of Uruguay in 2010 to that in 2011?
Ensure brevity in your answer.  0.92. What is the ratio of the Balance of Payment (as % of commercial service exports) in Congo (Democratic) in 2010 to that in 2012?
Offer a very short reply. 1.2. What is the ratio of the Balance of Payment (as % of commercial service exports) in Malta in 2010 to that in 2012?
Give a very brief answer. 2.18. What is the ratio of the Balance of Payment (as % of commercial service exports) in Uruguay in 2010 to that in 2012?
Offer a very short reply. 0.94. What is the ratio of the Balance of Payment (as % of commercial service exports) in Congo (Democratic) in 2010 to that in 2013?
Provide a short and direct response. 6.44. What is the ratio of the Balance of Payment (as % of commercial service exports) in Malta in 2010 to that in 2013?
Make the answer very short. 2.08. What is the ratio of the Balance of Payment (as % of commercial service exports) of Congo (Democratic) in 2011 to that in 2012?
Keep it short and to the point. 1.14. What is the ratio of the Balance of Payment (as % of commercial service exports) of Malta in 2011 to that in 2012?
Your answer should be compact. 2.26. What is the ratio of the Balance of Payment (as % of commercial service exports) of Uruguay in 2011 to that in 2012?
Your answer should be compact. 1.03. What is the ratio of the Balance of Payment (as % of commercial service exports) of Congo (Democratic) in 2011 to that in 2013?
Offer a terse response. 6.12. What is the ratio of the Balance of Payment (as % of commercial service exports) of Malta in 2011 to that in 2013?
Give a very brief answer. 2.15. What is the ratio of the Balance of Payment (as % of commercial service exports) of Uruguay in 2011 to that in 2013?
Ensure brevity in your answer.  1.08. What is the ratio of the Balance of Payment (as % of commercial service exports) in Congo (Democratic) in 2012 to that in 2013?
Your answer should be compact. 5.37. What is the ratio of the Balance of Payment (as % of commercial service exports) in Malta in 2012 to that in 2013?
Keep it short and to the point. 0.95. What is the ratio of the Balance of Payment (as % of commercial service exports) of Uruguay in 2012 to that in 2013?
Provide a short and direct response. 1.05. What is the difference between the highest and the second highest Balance of Payment (as % of commercial service exports) of Congo (Democratic)?
Offer a very short reply. 0.92. What is the difference between the highest and the second highest Balance of Payment (as % of commercial service exports) of Malta?
Offer a very short reply. 1.32. What is the difference between the highest and the second highest Balance of Payment (as % of commercial service exports) in Uruguay?
Make the answer very short. 1.68. What is the difference between the highest and the lowest Balance of Payment (as % of commercial service exports) in Congo (Democratic)?
Offer a terse response. 4.44. What is the difference between the highest and the lowest Balance of Payment (as % of commercial service exports) of Malta?
Provide a succinct answer. 18.88. What is the difference between the highest and the lowest Balance of Payment (as % of commercial service exports) of Uruguay?
Your answer should be very brief. 17.96. 